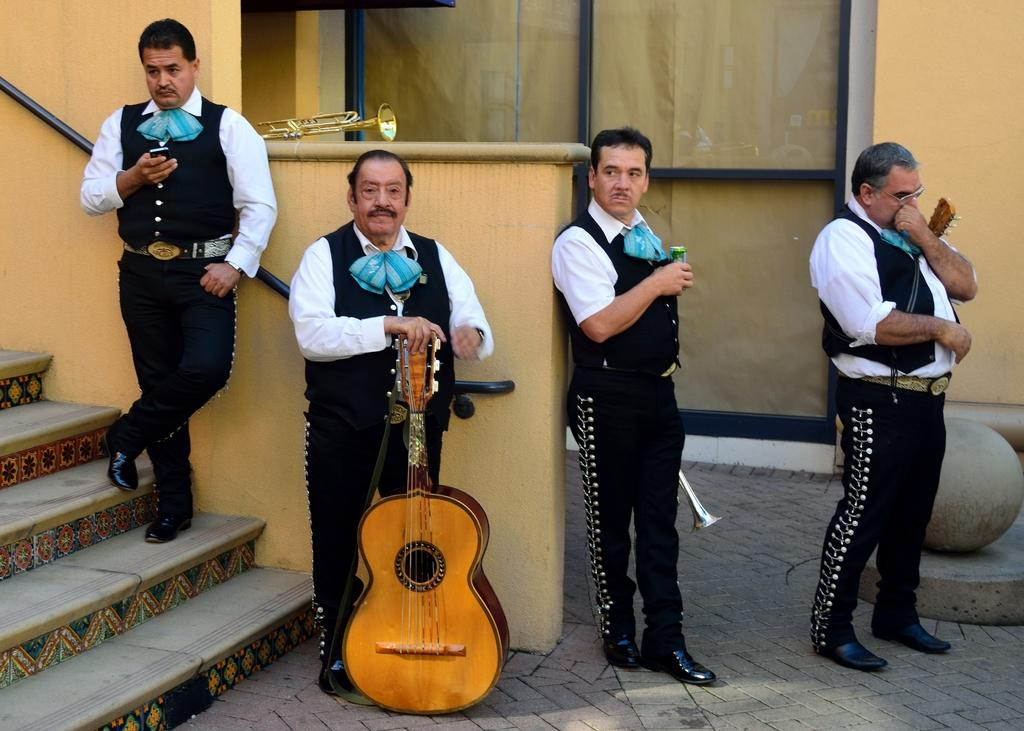How many people are in the image? There is a group of people in the image. What are the people doing in the image? The people are standing on the floor and holding a guitar and musical instruments. What architectural feature can be seen in the image? There is a staircase in the image. What else is visible in the image besides the people and staircase? There is a wall visible in the image. What type of hole can be seen in the image? There is no hole present in the image. What flavor of receipt is visible in the image? There is no receipt present in the image, and therefore no flavor can be determined. 